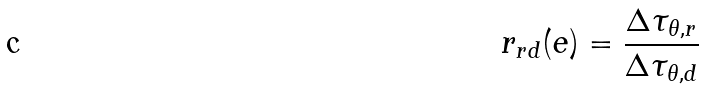Convert formula to latex. <formula><loc_0><loc_0><loc_500><loc_500>r _ { r d } ( e ) = \frac { \Delta \tau _ { \theta , r } } { \Delta \tau _ { \theta , d } }</formula> 